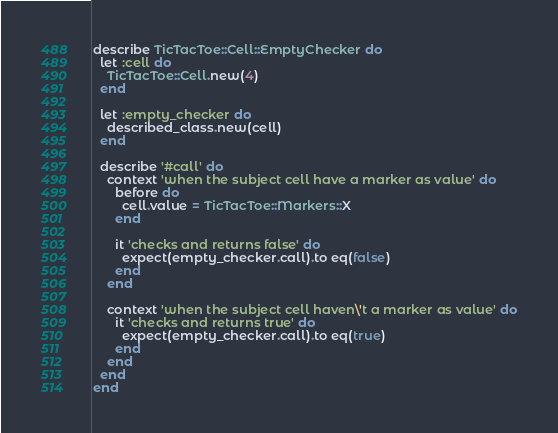<code> <loc_0><loc_0><loc_500><loc_500><_Ruby_>describe TicTacToe::Cell::EmptyChecker do
  let :cell do
    TicTacToe::Cell.new(4)
  end

  let :empty_checker do
    described_class.new(cell)
  end

  describe '#call' do
    context 'when the subject cell have a marker as value' do
      before do
        cell.value = TicTacToe::Markers::X
      end

      it 'checks and returns false' do
        expect(empty_checker.call).to eq(false)
      end
    end

    context 'when the subject cell haven\'t a marker as value' do
      it 'checks and returns true' do
        expect(empty_checker.call).to eq(true)
      end
    end
  end
end
</code> 